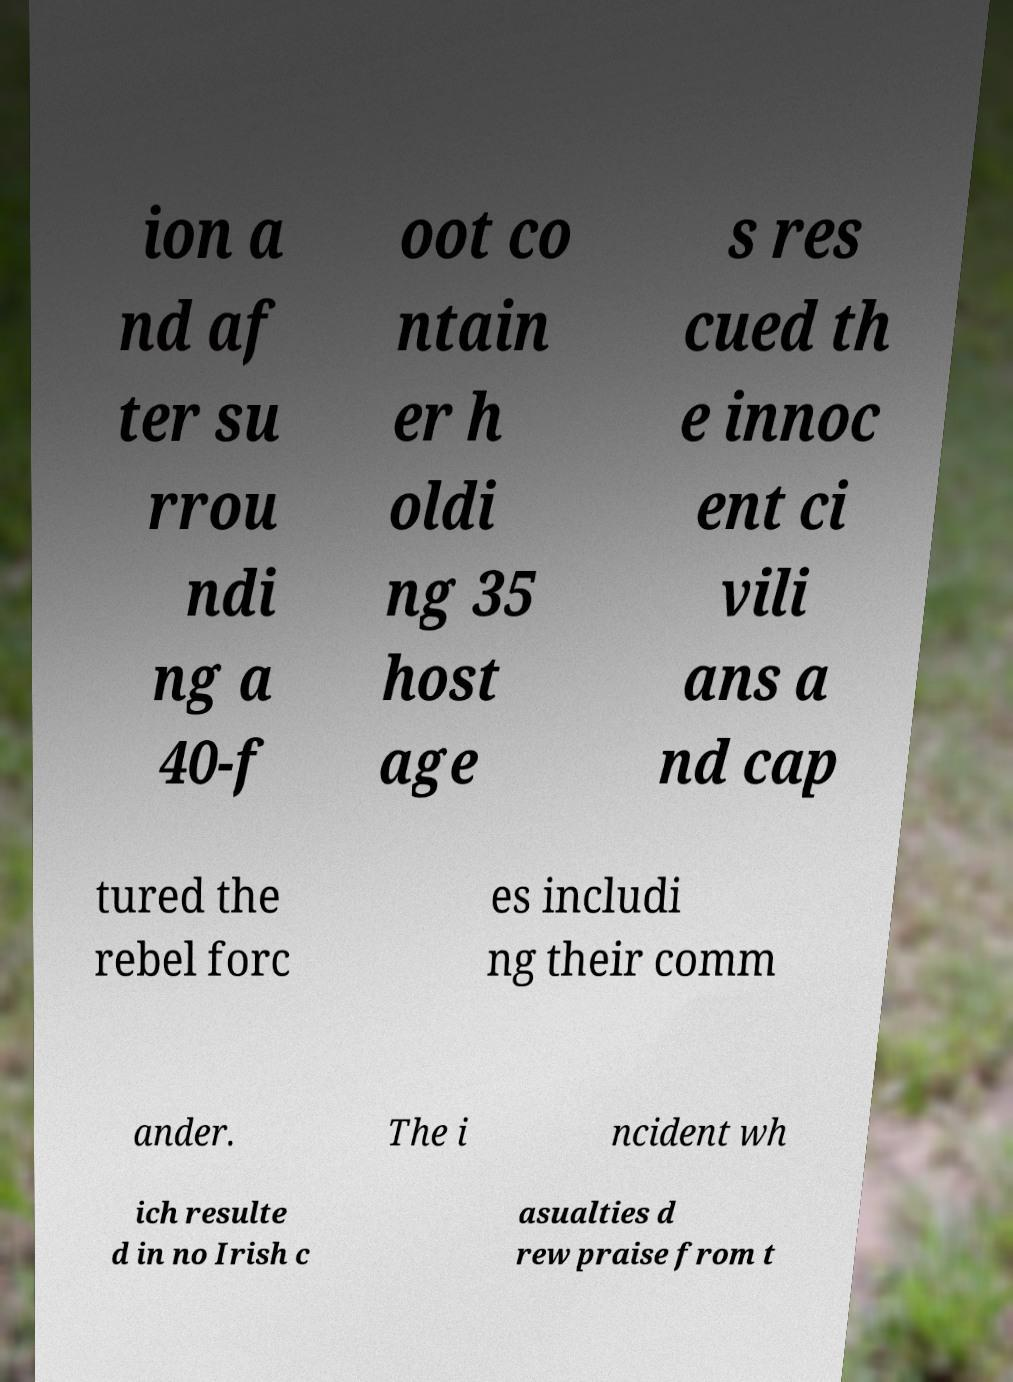What messages or text are displayed in this image? I need them in a readable, typed format. ion a nd af ter su rrou ndi ng a 40-f oot co ntain er h oldi ng 35 host age s res cued th e innoc ent ci vili ans a nd cap tured the rebel forc es includi ng their comm ander. The i ncident wh ich resulte d in no Irish c asualties d rew praise from t 